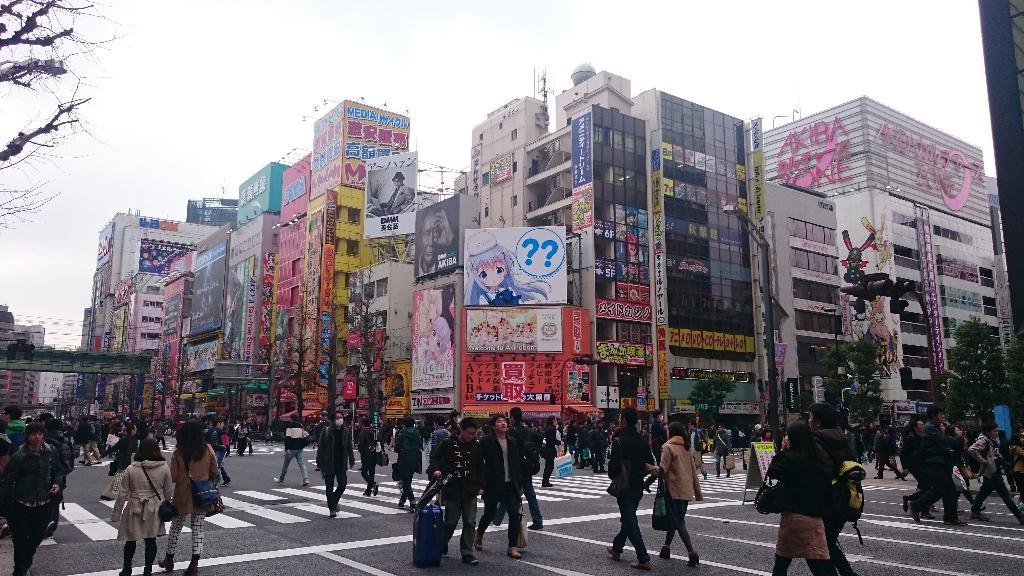What type of structures can be seen in the image? There are buildings in the image. What other natural elements are present in the image? There are trees in the image. What objects are placed near the buildings? There are boards in the image. Who or what is located at the bottom of the image? There are people at the bottom of the image. What type of pathway is visible in the image? There is a road visible in the image. What can be seen in the background of the image? There is sky in the background of the image. What architectural feature is present on the left side of the image? There is a bridge on the left side of the image. Can you observe any tubs or space-related objects in the image? There are no tubs or space-related objects present in the image. Is there an observation deck visible in the image? There is no observation deck present in the image. 